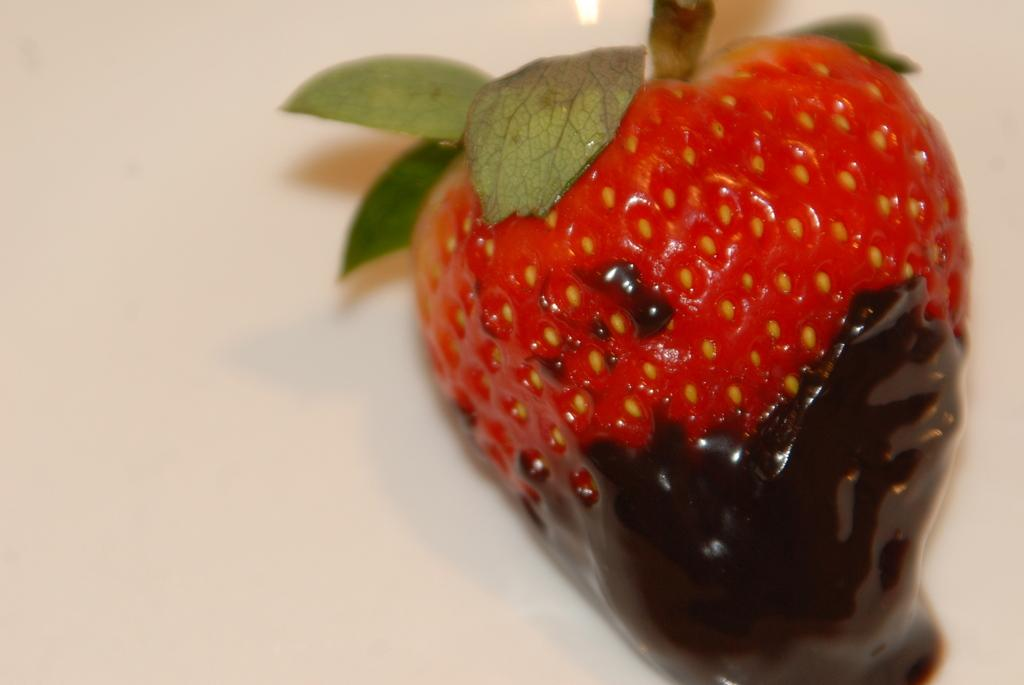What type of fruit is in the image? There is a strawberry in the image. What is attached to the strawberry? There are leaves associated with the strawberry. What is covering the strawberry? There is cream on the strawberry. What color is the background of the image? The background of the image is white. What type of toys can be seen playing with the plough in the image? There are no toys or plough present in the image; it features a strawberry with leaves and cream. 